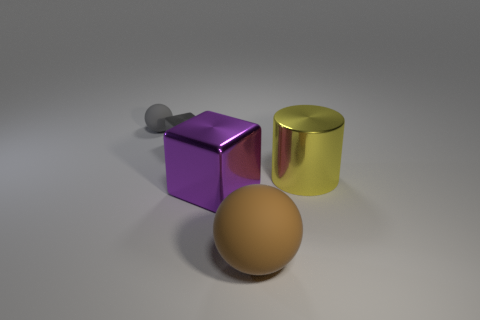Subtract all yellow balls. Subtract all red cylinders. How many balls are left? 2 Add 3 big objects. How many objects exist? 8 Subtract all gray blocks. How many blocks are left? 1 Subtract all cylinders. How many objects are left? 4 Subtract 1 blocks. How many blocks are left? 1 Subtract all cyan cubes. How many gray balls are left? 1 Subtract all red matte cylinders. Subtract all gray balls. How many objects are left? 4 Add 5 brown rubber things. How many brown rubber things are left? 6 Add 4 big rubber objects. How many big rubber objects exist? 5 Subtract 0 red blocks. How many objects are left? 5 